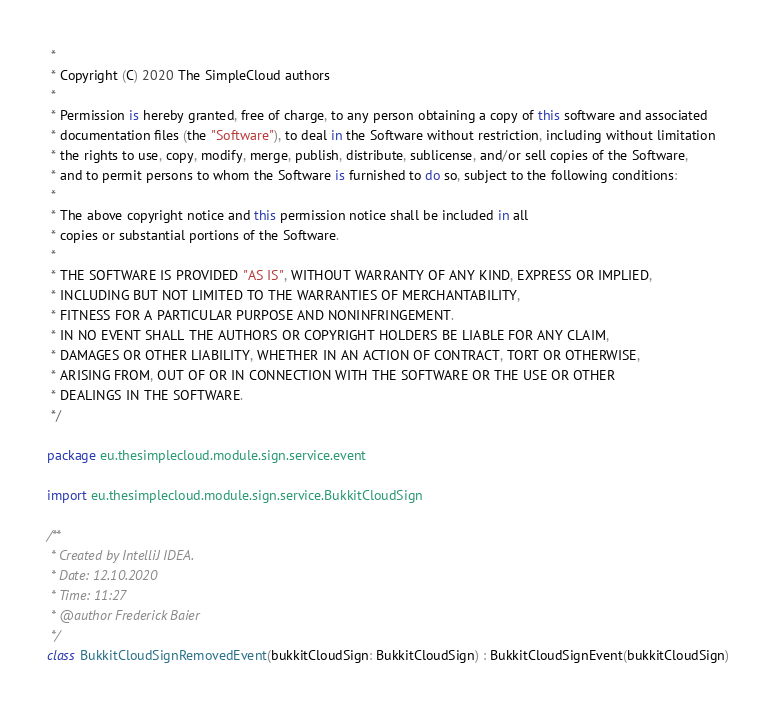<code> <loc_0><loc_0><loc_500><loc_500><_Kotlin_> *
 * Copyright (C) 2020 The SimpleCloud authors
 *
 * Permission is hereby granted, free of charge, to any person obtaining a copy of this software and associated
 * documentation files (the "Software"), to deal in the Software without restriction, including without limitation
 * the rights to use, copy, modify, merge, publish, distribute, sublicense, and/or sell copies of the Software,
 * and to permit persons to whom the Software is furnished to do so, subject to the following conditions:
 *
 * The above copyright notice and this permission notice shall be included in all
 * copies or substantial portions of the Software.
 *
 * THE SOFTWARE IS PROVIDED "AS IS", WITHOUT WARRANTY OF ANY KIND, EXPRESS OR IMPLIED,
 * INCLUDING BUT NOT LIMITED TO THE WARRANTIES OF MERCHANTABILITY,
 * FITNESS FOR A PARTICULAR PURPOSE AND NONINFRINGEMENT.
 * IN NO EVENT SHALL THE AUTHORS OR COPYRIGHT HOLDERS BE LIABLE FOR ANY CLAIM,
 * DAMAGES OR OTHER LIABILITY, WHETHER IN AN ACTION OF CONTRACT, TORT OR OTHERWISE,
 * ARISING FROM, OUT OF OR IN CONNECTION WITH THE SOFTWARE OR THE USE OR OTHER
 * DEALINGS IN THE SOFTWARE.
 */

package eu.thesimplecloud.module.sign.service.event

import eu.thesimplecloud.module.sign.service.BukkitCloudSign

/**
 * Created by IntelliJ IDEA.
 * Date: 12.10.2020
 * Time: 11:27
 * @author Frederick Baier
 */
class BukkitCloudSignRemovedEvent(bukkitCloudSign: BukkitCloudSign) : BukkitCloudSignEvent(bukkitCloudSign)</code> 